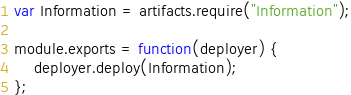<code> <loc_0><loc_0><loc_500><loc_500><_JavaScript_>var Information = artifacts.require("Information");

module.exports = function(deployer) {
    deployer.deploy(Information);
};

</code> 